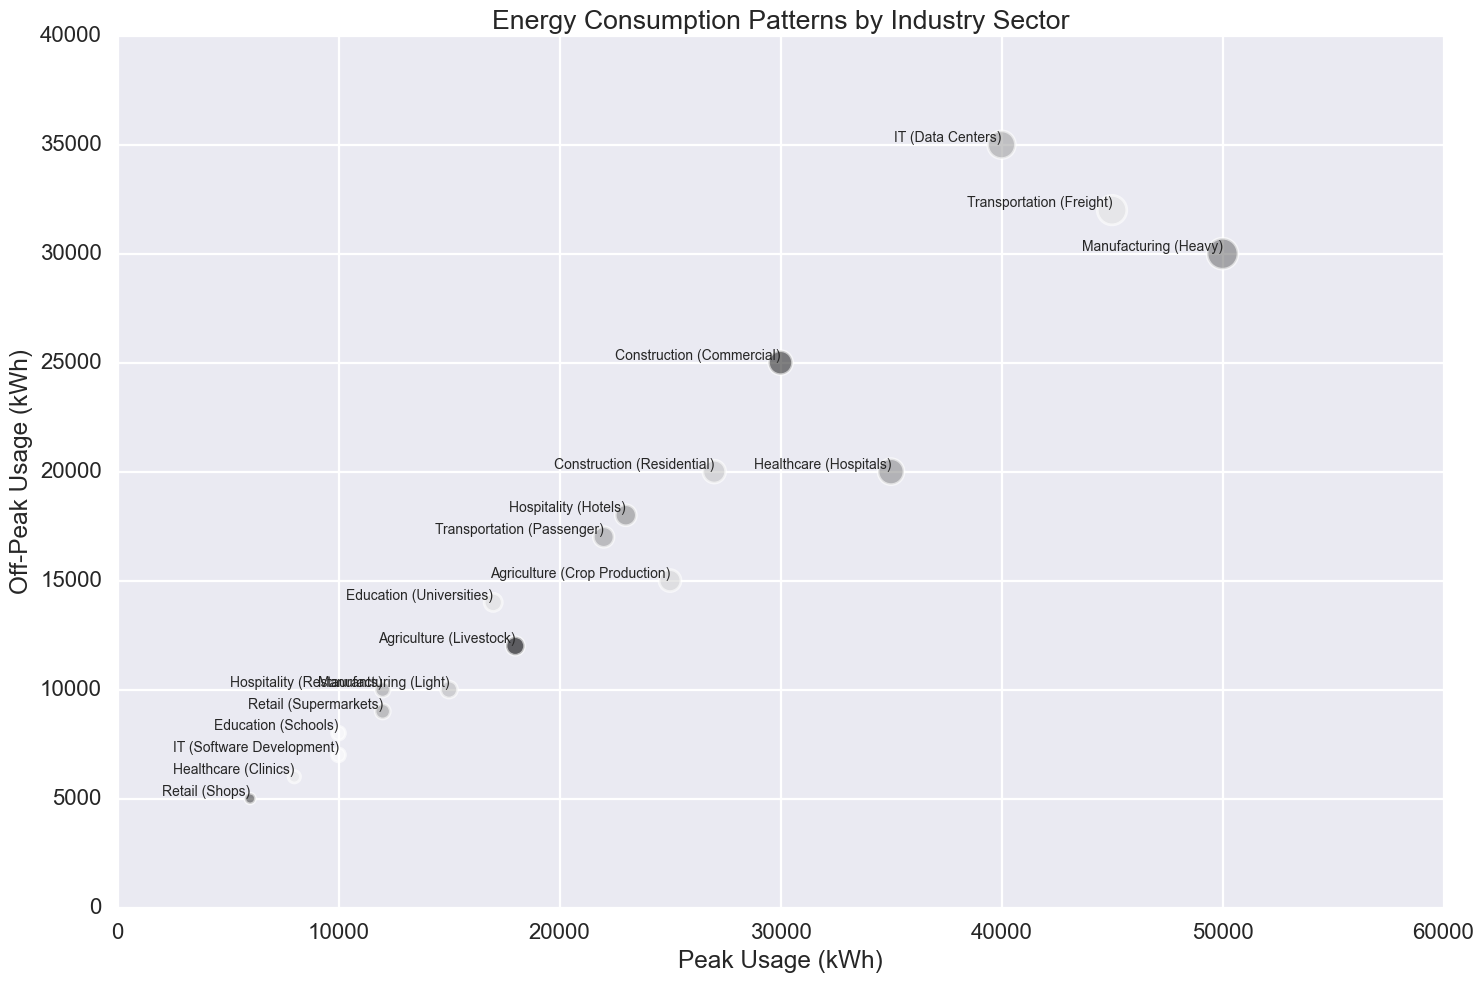What industry sector has the highest peak energy usage? The bubble chart shows that the "Manufacturing (Heavy)" sector has the largest bubble, indicating the highest peak usage.
Answer: Manufacturing (Heavy) Which sector within the IT industry has a higher off-peak usage? By comparing the positions of the bubbles labeled "IT (Data Centers)" and "IT (Software Development)", "IT (Data Centers)" is positioned higher on the y-axis, indicating higher off-peak usage.
Answer: Data Centers How does the peak usage of Transportation (Freight) compare to that of Manufacturing (Light)? The bubble for "Transportation (Freight)" is further to the right on the x-axis than "Manufacturing (Light)", indicating a higher peak usage.
Answer: Higher Which industry sector consumes more energy off-peak: Healthcare (Hospitals) or Education (Universities)? By comparing the y-axis positions of the bubbles for "Healthcare (Hospitals)" and "Education (Universities)," "Healthcare (Hospitals)" is higher, indicating more off-peak usage.
Answer: Healthcare (Hospitals) Calculate the total peak usage for the Construction industry. Add the peak usage values of "Construction (Residential)" (27000) and "Construction (Commercial)" (30000): 27000 + 30000 = 57000.
Answer: 57000 Which has a larger bubble size: Agriculture (Crop Production) or Hospitality (Hotels)? The bubble size for "Agriculture (Crop Production)" is larger than "Hospitality (Hotels)", indicating higher peak usage.
Answer: Agriculture (Crop Production) What is the average off-peak usage for the Retail sector? Add the off-peak usage values of "Retail (Supermarkets)" (9000) and "Retail (Shops)" (5000) and divide by 2: (9000 + 5000) / 2 = 7000.
Answer: 7000 Compare the peak and off-peak energy usage for the Hospitality (Restaurants) sector. The bubble is situated at the coordinates (peak usage: 12000, off-peak usage: 10000), with the peak usage being 2000 units higher than the off-peak usage.
Answer: Peak usage is higher by 2000 units Which sector within the Healthcare industry uses more energy off-peak? Comparing the y-axis positions, "Healthcare (Hospitals)" is positioned higher than “Healthcare (Clinics)", indicating higher off-peak usage.
Answer: Hospitals What is the total off-peak usage for the Transportation industry? Add the off-peak usage values of "Transportation (Freight)" (32000) and "Transportation (Passenger)" (17000): 32000 + 17000 = 49000.
Answer: 49000 